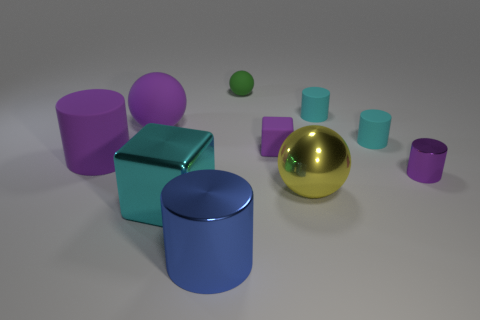Subtract 2 cylinders. How many cylinders are left? 3 Subtract all cubes. How many objects are left? 8 Subtract 1 purple spheres. How many objects are left? 9 Subtract all small red matte spheres. Subtract all yellow objects. How many objects are left? 9 Add 8 big cyan blocks. How many big cyan blocks are left? 9 Add 1 cylinders. How many cylinders exist? 6 